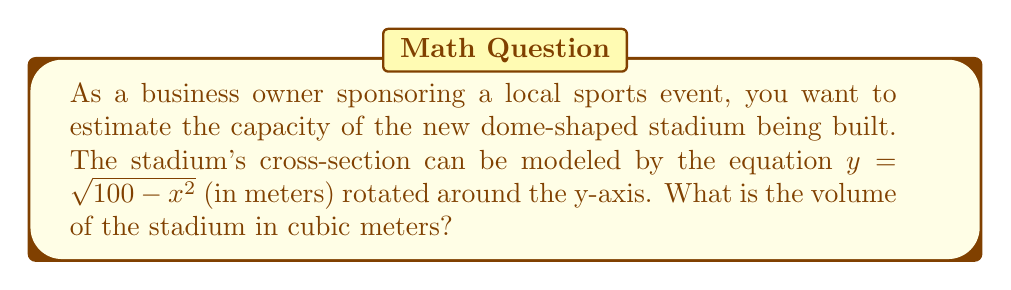Give your solution to this math problem. To solve this problem, we'll use the shell method for computing the volume of a solid of revolution. Here's the step-by-step process:

1) The stadium is formed by rotating the curve $y = \sqrt{100 - x^2}$ around the y-axis from $x = 0$ to $x = 10$.

2) The shell method formula for volume is:

   $$V = 2\pi \int_a^b x f(x) dx$$

   where $f(x) = \sqrt{100 - x^2}$, $a = 0$, and $b = 10$.

3) Substituting these into our formula:

   $$V = 2\pi \int_0^{10} x \sqrt{100 - x^2} dx$$

4) This integral is challenging to solve directly. Let's use substitution:
   Let $u = 100 - x^2$, then $du = -2x dx$ or $x dx = -\frac{1}{2} du$

5) When $x = 0$, $u = 100$; when $x = 10$, $u = 0$. Our new integral becomes:

   $$V = 2\pi \int_{100}^0 -\frac{1}{2} \sqrt{u} du = \pi \int_0^{100} \sqrt{u} du$$

6) Now we can integrate:

   $$V = \pi [\frac{2}{3}u^{3/2}]_0^{100} = \pi (\frac{2}{3} \cdot 1000 - 0) = \frac{2000\pi}{3}$$

7) Therefore, the volume of the stadium is $\frac{2000\pi}{3}$ cubic meters.
Answer: $\frac{2000\pi}{3}$ cubic meters 